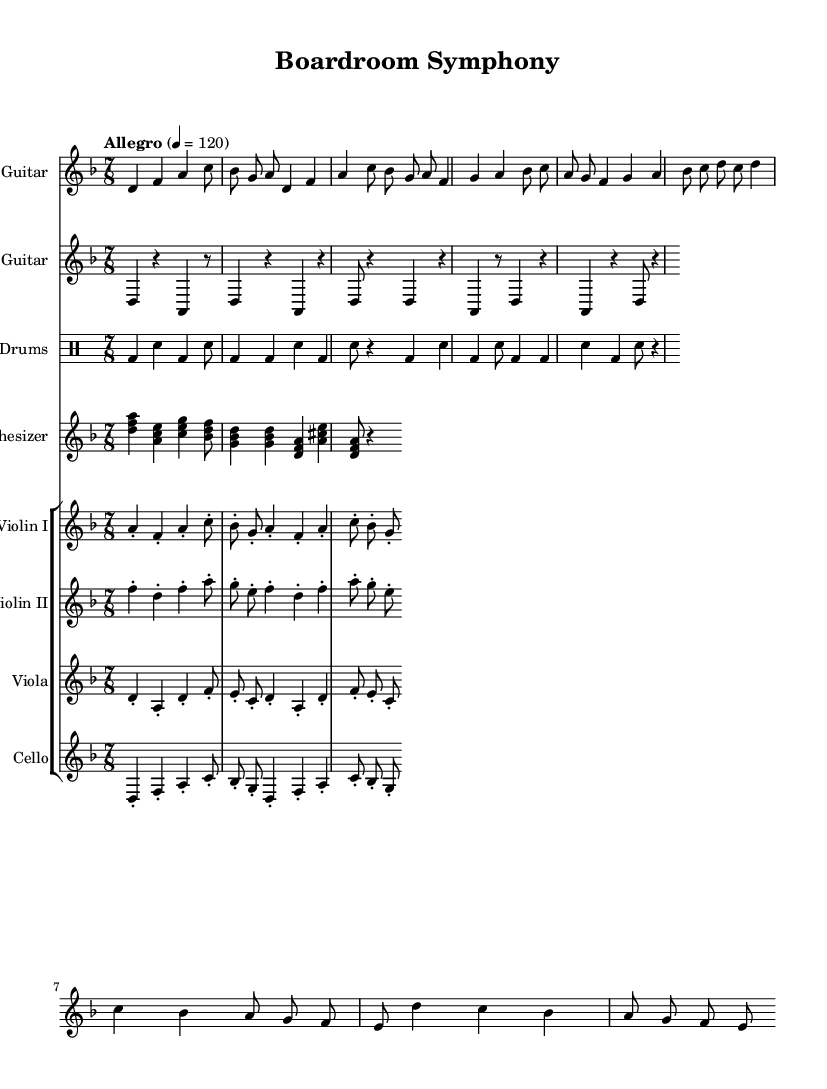What is the key signature of this music? The key signature is indicated at the beginning of the score, where there are two flats, which corresponds to D minor.
Answer: D minor What is the time signature of the piece? The time signature appears right after the key signature and is shown as seven eighth notes, indicating a time signature of 7/8.
Answer: 7/8 What is the tempo marking for the piece? The tempo marking is found in the global section, stating "Allegro" with a metronome indication of quarter note equals 120 beats per minute.
Answer: Allegro, 4 = 120 How many measures are in the electric guitar part? By counting each measure in the electric guitar staff, we find a total of eight measures in the provided section of the score.
Answer: Eight Which string instruments are included in the score? The score specifies four string instruments grouped together: Violin I, Violin II, Viola, and Cello.
Answer: Violin I, Violin II, Viola, Cello What rhythmic division is frequently used in the drums section? The drum notation shows a pattern where the bass drum and snare drum alternate using quarter notes and eighth notes, indicating a strong dominance of these rhythmic divisions.
Answer: Quarter and eighth notes What does the synthesizer staff showcase in terms of chord quality? The synthesizer part presents several triads and seventh chords, prominently showcasing major and minor chord qualities throughout the section.
Answer: Major and minor chords 